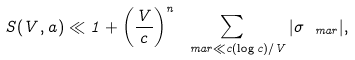<formula> <loc_0><loc_0><loc_500><loc_500>S ( V , a ) \ll 1 + \left ( \frac { V } { c } \right ) ^ { n } \sum _ { \ m a { r } \ll c ( \log c ) / V } | \sigma _ { \ m a { r } } | ,</formula> 